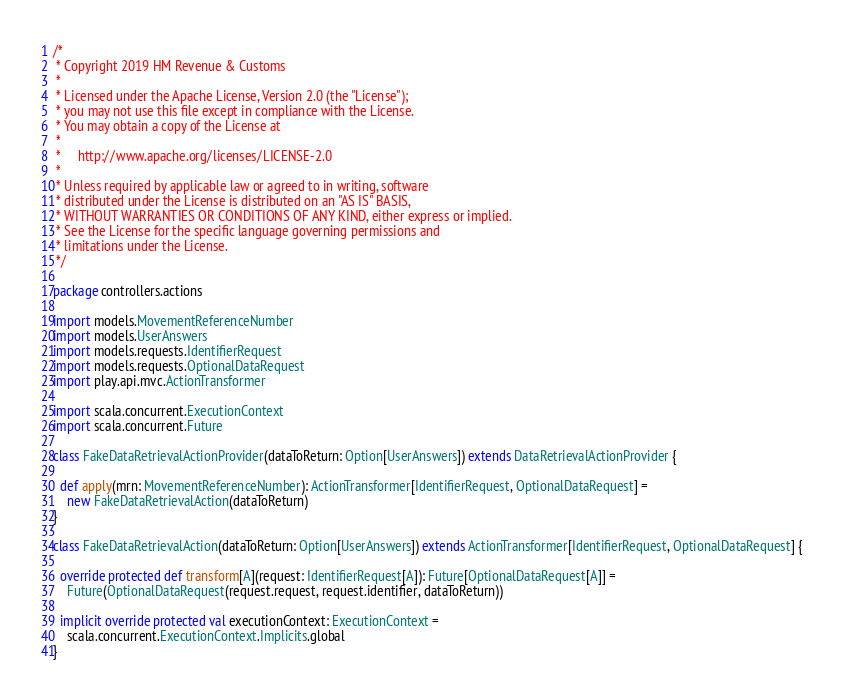Convert code to text. <code><loc_0><loc_0><loc_500><loc_500><_Scala_>/*
 * Copyright 2019 HM Revenue & Customs
 *
 * Licensed under the Apache License, Version 2.0 (the "License");
 * you may not use this file except in compliance with the License.
 * You may obtain a copy of the License at
 *
 *     http://www.apache.org/licenses/LICENSE-2.0
 *
 * Unless required by applicable law or agreed to in writing, software
 * distributed under the License is distributed on an "AS IS" BASIS,
 * WITHOUT WARRANTIES OR CONDITIONS OF ANY KIND, either express or implied.
 * See the License for the specific language governing permissions and
 * limitations under the License.
 */

package controllers.actions

import models.MovementReferenceNumber
import models.UserAnswers
import models.requests.IdentifierRequest
import models.requests.OptionalDataRequest
import play.api.mvc.ActionTransformer

import scala.concurrent.ExecutionContext
import scala.concurrent.Future

class FakeDataRetrievalActionProvider(dataToReturn: Option[UserAnswers]) extends DataRetrievalActionProvider {

  def apply(mrn: MovementReferenceNumber): ActionTransformer[IdentifierRequest, OptionalDataRequest] =
    new FakeDataRetrievalAction(dataToReturn)
}

class FakeDataRetrievalAction(dataToReturn: Option[UserAnswers]) extends ActionTransformer[IdentifierRequest, OptionalDataRequest] {

  override protected def transform[A](request: IdentifierRequest[A]): Future[OptionalDataRequest[A]] =
    Future(OptionalDataRequest(request.request, request.identifier, dataToReturn))

  implicit override protected val executionContext: ExecutionContext =
    scala.concurrent.ExecutionContext.Implicits.global
}
</code> 